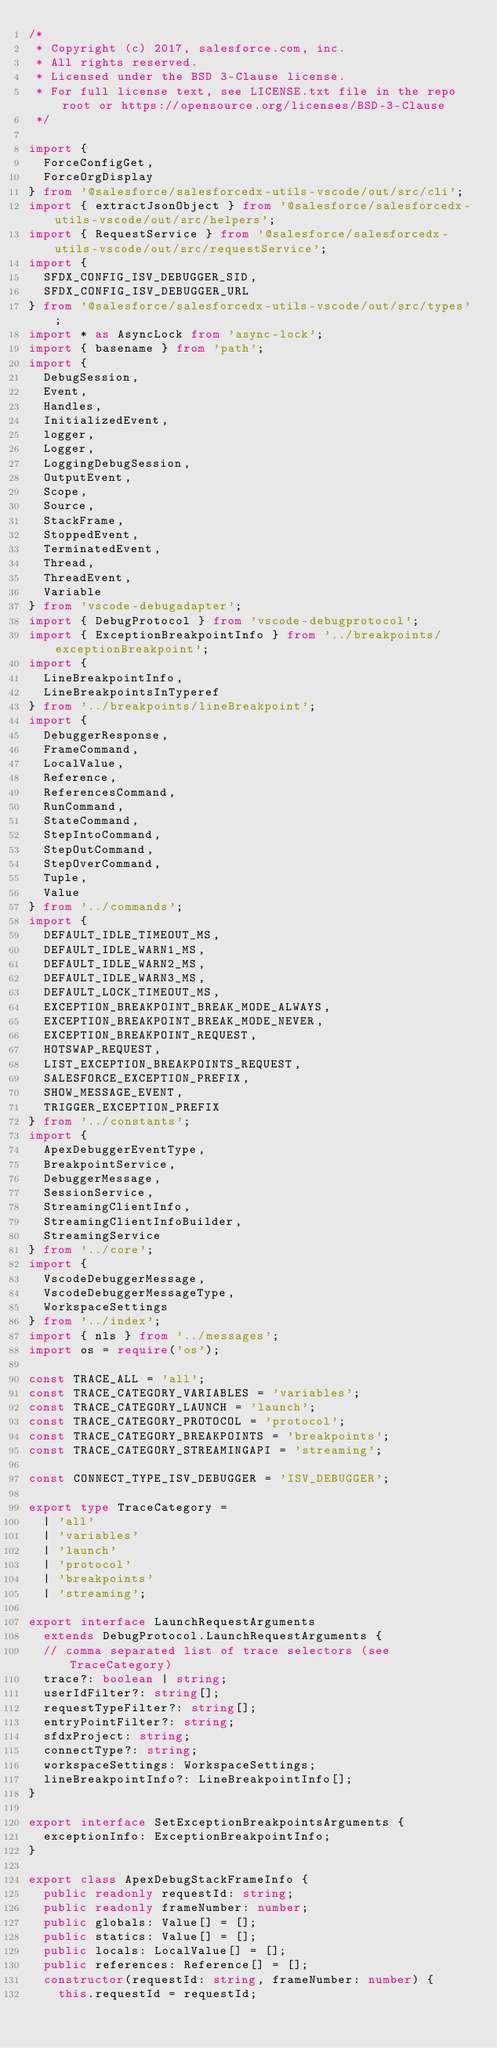Convert code to text. <code><loc_0><loc_0><loc_500><loc_500><_TypeScript_>/*
 * Copyright (c) 2017, salesforce.com, inc.
 * All rights reserved.
 * Licensed under the BSD 3-Clause license.
 * For full license text, see LICENSE.txt file in the repo root or https://opensource.org/licenses/BSD-3-Clause
 */

import {
  ForceConfigGet,
  ForceOrgDisplay
} from '@salesforce/salesforcedx-utils-vscode/out/src/cli';
import { extractJsonObject } from '@salesforce/salesforcedx-utils-vscode/out/src/helpers';
import { RequestService } from '@salesforce/salesforcedx-utils-vscode/out/src/requestService';
import {
  SFDX_CONFIG_ISV_DEBUGGER_SID,
  SFDX_CONFIG_ISV_DEBUGGER_URL
} from '@salesforce/salesforcedx-utils-vscode/out/src/types';
import * as AsyncLock from 'async-lock';
import { basename } from 'path';
import {
  DebugSession,
  Event,
  Handles,
  InitializedEvent,
  logger,
  Logger,
  LoggingDebugSession,
  OutputEvent,
  Scope,
  Source,
  StackFrame,
  StoppedEvent,
  TerminatedEvent,
  Thread,
  ThreadEvent,
  Variable
} from 'vscode-debugadapter';
import { DebugProtocol } from 'vscode-debugprotocol';
import { ExceptionBreakpointInfo } from '../breakpoints/exceptionBreakpoint';
import {
  LineBreakpointInfo,
  LineBreakpointsInTyperef
} from '../breakpoints/lineBreakpoint';
import {
  DebuggerResponse,
  FrameCommand,
  LocalValue,
  Reference,
  ReferencesCommand,
  RunCommand,
  StateCommand,
  StepIntoCommand,
  StepOutCommand,
  StepOverCommand,
  Tuple,
  Value
} from '../commands';
import {
  DEFAULT_IDLE_TIMEOUT_MS,
  DEFAULT_IDLE_WARN1_MS,
  DEFAULT_IDLE_WARN2_MS,
  DEFAULT_IDLE_WARN3_MS,
  DEFAULT_LOCK_TIMEOUT_MS,
  EXCEPTION_BREAKPOINT_BREAK_MODE_ALWAYS,
  EXCEPTION_BREAKPOINT_BREAK_MODE_NEVER,
  EXCEPTION_BREAKPOINT_REQUEST,
  HOTSWAP_REQUEST,
  LIST_EXCEPTION_BREAKPOINTS_REQUEST,
  SALESFORCE_EXCEPTION_PREFIX,
  SHOW_MESSAGE_EVENT,
  TRIGGER_EXCEPTION_PREFIX
} from '../constants';
import {
  ApexDebuggerEventType,
  BreakpointService,
  DebuggerMessage,
  SessionService,
  StreamingClientInfo,
  StreamingClientInfoBuilder,
  StreamingService
} from '../core';
import {
  VscodeDebuggerMessage,
  VscodeDebuggerMessageType,
  WorkspaceSettings
} from '../index';
import { nls } from '../messages';
import os = require('os');

const TRACE_ALL = 'all';
const TRACE_CATEGORY_VARIABLES = 'variables';
const TRACE_CATEGORY_LAUNCH = 'launch';
const TRACE_CATEGORY_PROTOCOL = 'protocol';
const TRACE_CATEGORY_BREAKPOINTS = 'breakpoints';
const TRACE_CATEGORY_STREAMINGAPI = 'streaming';

const CONNECT_TYPE_ISV_DEBUGGER = 'ISV_DEBUGGER';

export type TraceCategory =
  | 'all'
  | 'variables'
  | 'launch'
  | 'protocol'
  | 'breakpoints'
  | 'streaming';

export interface LaunchRequestArguments
  extends DebugProtocol.LaunchRequestArguments {
  // comma separated list of trace selectors (see TraceCategory)
  trace?: boolean | string;
  userIdFilter?: string[];
  requestTypeFilter?: string[];
  entryPointFilter?: string;
  sfdxProject: string;
  connectType?: string;
  workspaceSettings: WorkspaceSettings;
  lineBreakpointInfo?: LineBreakpointInfo[];
}

export interface SetExceptionBreakpointsArguments {
  exceptionInfo: ExceptionBreakpointInfo;
}

export class ApexDebugStackFrameInfo {
  public readonly requestId: string;
  public readonly frameNumber: number;
  public globals: Value[] = [];
  public statics: Value[] = [];
  public locals: LocalValue[] = [];
  public references: Reference[] = [];
  constructor(requestId: string, frameNumber: number) {
    this.requestId = requestId;</code> 